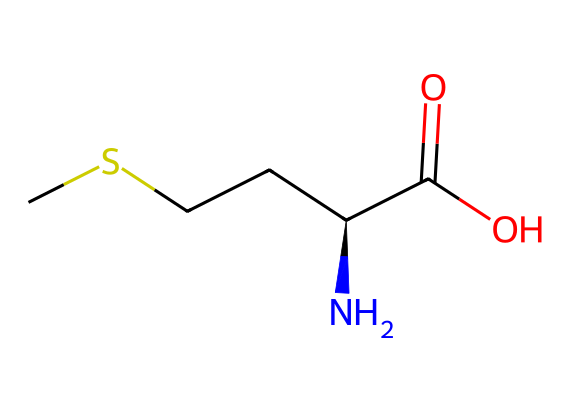how many carbon atoms are in methionine? By examining the SMILES representation, we can count the carbon atoms represented in it. The structure shows five carbon atoms (C) total, as indicated by the symbols and their connections.
Answer: five what functional groups are present in methionine? The SMILES notation shows a carboxylic acid group (C(=O)O) and an amine group (N) connected to the carbon chain. These two groups are characteristic functional groups in amino acids.
Answer: carboxylic acid, amine what type of amino acid is methionine? Methionine has a sulfur atom (S) in its side chain, which classifies it as a sulfur-containing amino acid among the amino acids.
Answer: sulfur-containing what is the total number of nitrogen atoms in methionine? In the provided structure, there is one nitrogen atom present in the amine group (N), denoted by the letter in the SMILES.
Answer: one what is the significance of methionine for muscle health? Methionine is an essential amino acid that plays a crucial role in protein synthesis, which is fundamental for muscle repair and growth. Its presence is necessary for maintaining healthy muscle tissue.
Answer: essential for muscle repair how does the presence of sulfur impact the properties of methionine? The sulfur atom (S) in methionine contributes to the formation of disulfide bonds in proteins, influencing protein structure, stability, and function. This characteristic is important for the overall function of proteins in muscles.
Answer: forms disulfide bonds what is the molecular formula of methionine? From the SMILES structure, we can deduce the counts of each type of atom. There are 5 carbons, 11 hydrogens, 2 oxygens, 1 nitrogen, and 1 sulfur, leading us to its molecular formula.
Answer: C5H11NO2S 